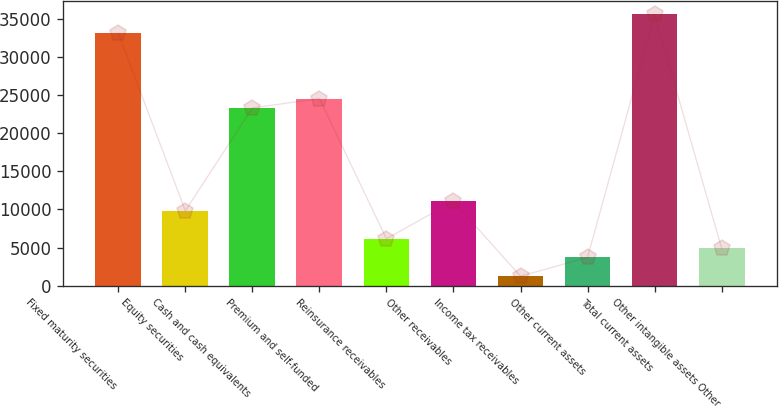Convert chart. <chart><loc_0><loc_0><loc_500><loc_500><bar_chart><fcel>Fixed maturity securities<fcel>Equity securities<fcel>Cash and cash equivalents<fcel>Premium and self-funded<fcel>Reinsurance receivables<fcel>Other receivables<fcel>Income tax receivables<fcel>Other current assets<fcel>Total current assets<fcel>Other intangible assets Other<nl><fcel>33189<fcel>9834.76<fcel>23355.6<fcel>24584.8<fcel>6147.25<fcel>11063.9<fcel>1230.57<fcel>3688.91<fcel>35647.3<fcel>4918.08<nl></chart> 